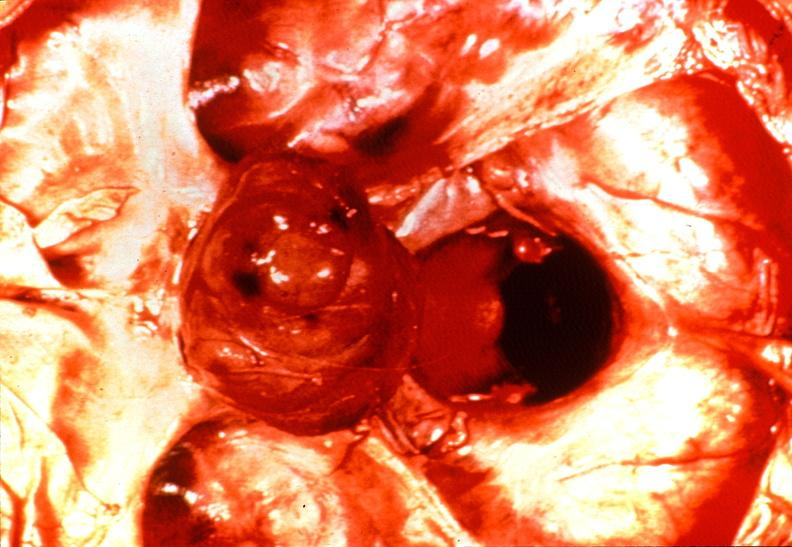does this image show pituitary, chromaphobe adenoma?
Answer the question using a single word or phrase. Yes 